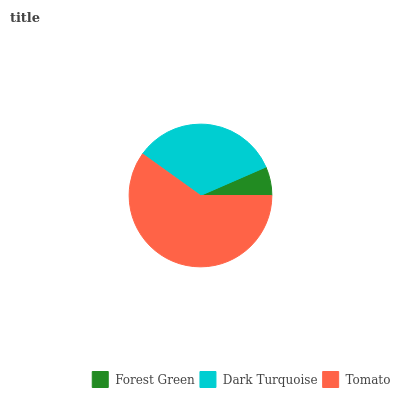Is Forest Green the minimum?
Answer yes or no. Yes. Is Tomato the maximum?
Answer yes or no. Yes. Is Dark Turquoise the minimum?
Answer yes or no. No. Is Dark Turquoise the maximum?
Answer yes or no. No. Is Dark Turquoise greater than Forest Green?
Answer yes or no. Yes. Is Forest Green less than Dark Turquoise?
Answer yes or no. Yes. Is Forest Green greater than Dark Turquoise?
Answer yes or no. No. Is Dark Turquoise less than Forest Green?
Answer yes or no. No. Is Dark Turquoise the high median?
Answer yes or no. Yes. Is Dark Turquoise the low median?
Answer yes or no. Yes. Is Forest Green the high median?
Answer yes or no. No. Is Tomato the low median?
Answer yes or no. No. 